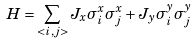Convert formula to latex. <formula><loc_0><loc_0><loc_500><loc_500>H = \sum _ { < i , j > } J _ { x } \sigma _ { i } ^ { x } \sigma _ { j } ^ { x } + J _ { y } \sigma _ { i } ^ { y } \sigma _ { j } ^ { y }</formula> 